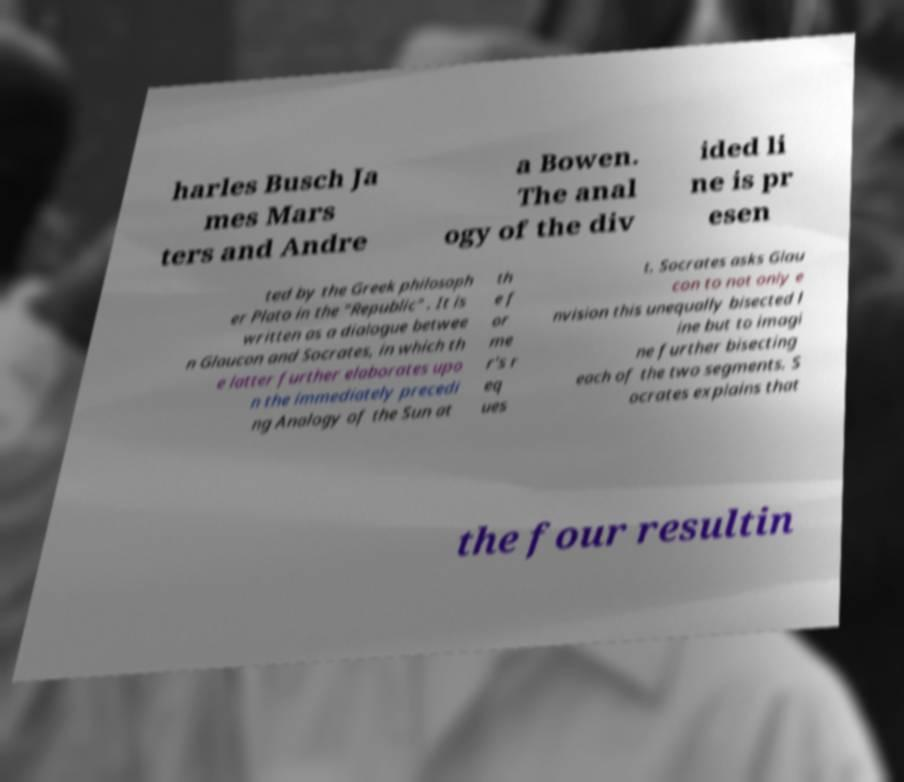I need the written content from this picture converted into text. Can you do that? harles Busch Ja mes Mars ters and Andre a Bowen. The anal ogy of the div ided li ne is pr esen ted by the Greek philosoph er Plato in the "Republic" . It is written as a dialogue betwee n Glaucon and Socrates, in which th e latter further elaborates upo n the immediately precedi ng Analogy of the Sun at th e f or me r's r eq ues t. Socrates asks Glau con to not only e nvision this unequally bisected l ine but to imagi ne further bisecting each of the two segments. S ocrates explains that the four resultin 